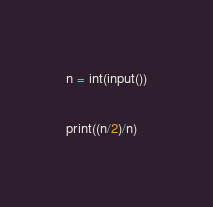Convert code to text. <code><loc_0><loc_0><loc_500><loc_500><_Python_>n = int(input())

print((n/2)/n)</code> 